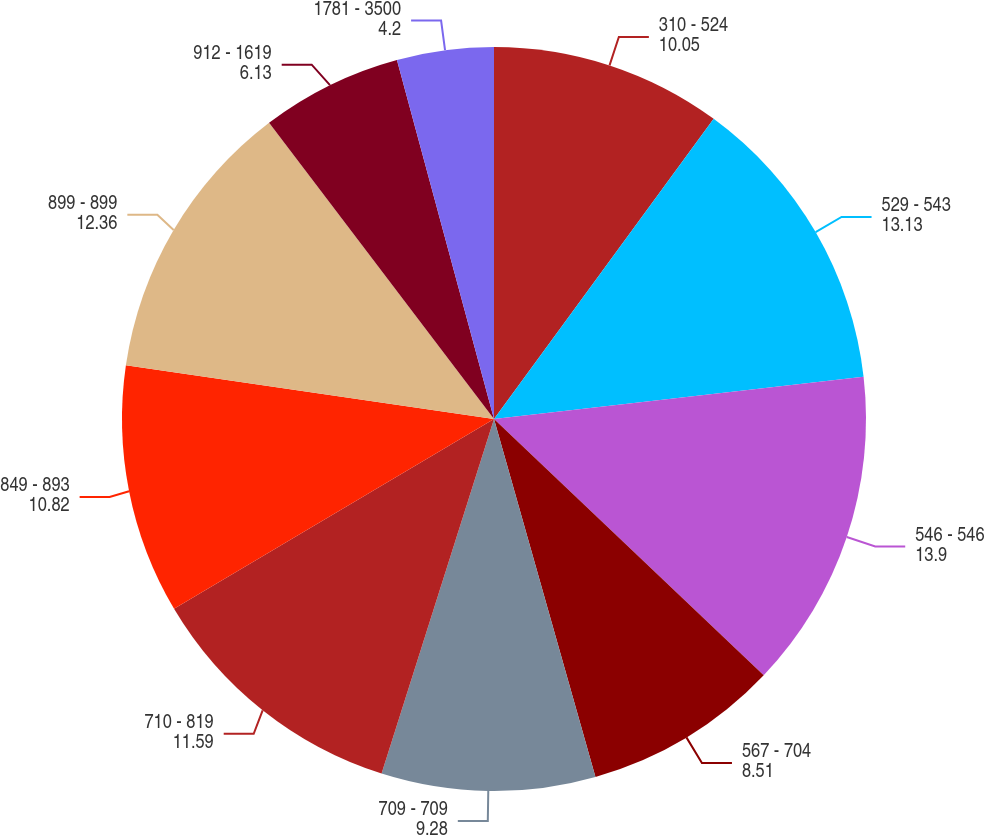<chart> <loc_0><loc_0><loc_500><loc_500><pie_chart><fcel>310 - 524<fcel>529 - 543<fcel>546 - 546<fcel>567 - 704<fcel>709 - 709<fcel>710 - 819<fcel>849 - 893<fcel>899 - 899<fcel>912 - 1619<fcel>1781 - 3500<nl><fcel>10.05%<fcel>13.13%<fcel>13.9%<fcel>8.51%<fcel>9.28%<fcel>11.59%<fcel>10.82%<fcel>12.36%<fcel>6.13%<fcel>4.2%<nl></chart> 